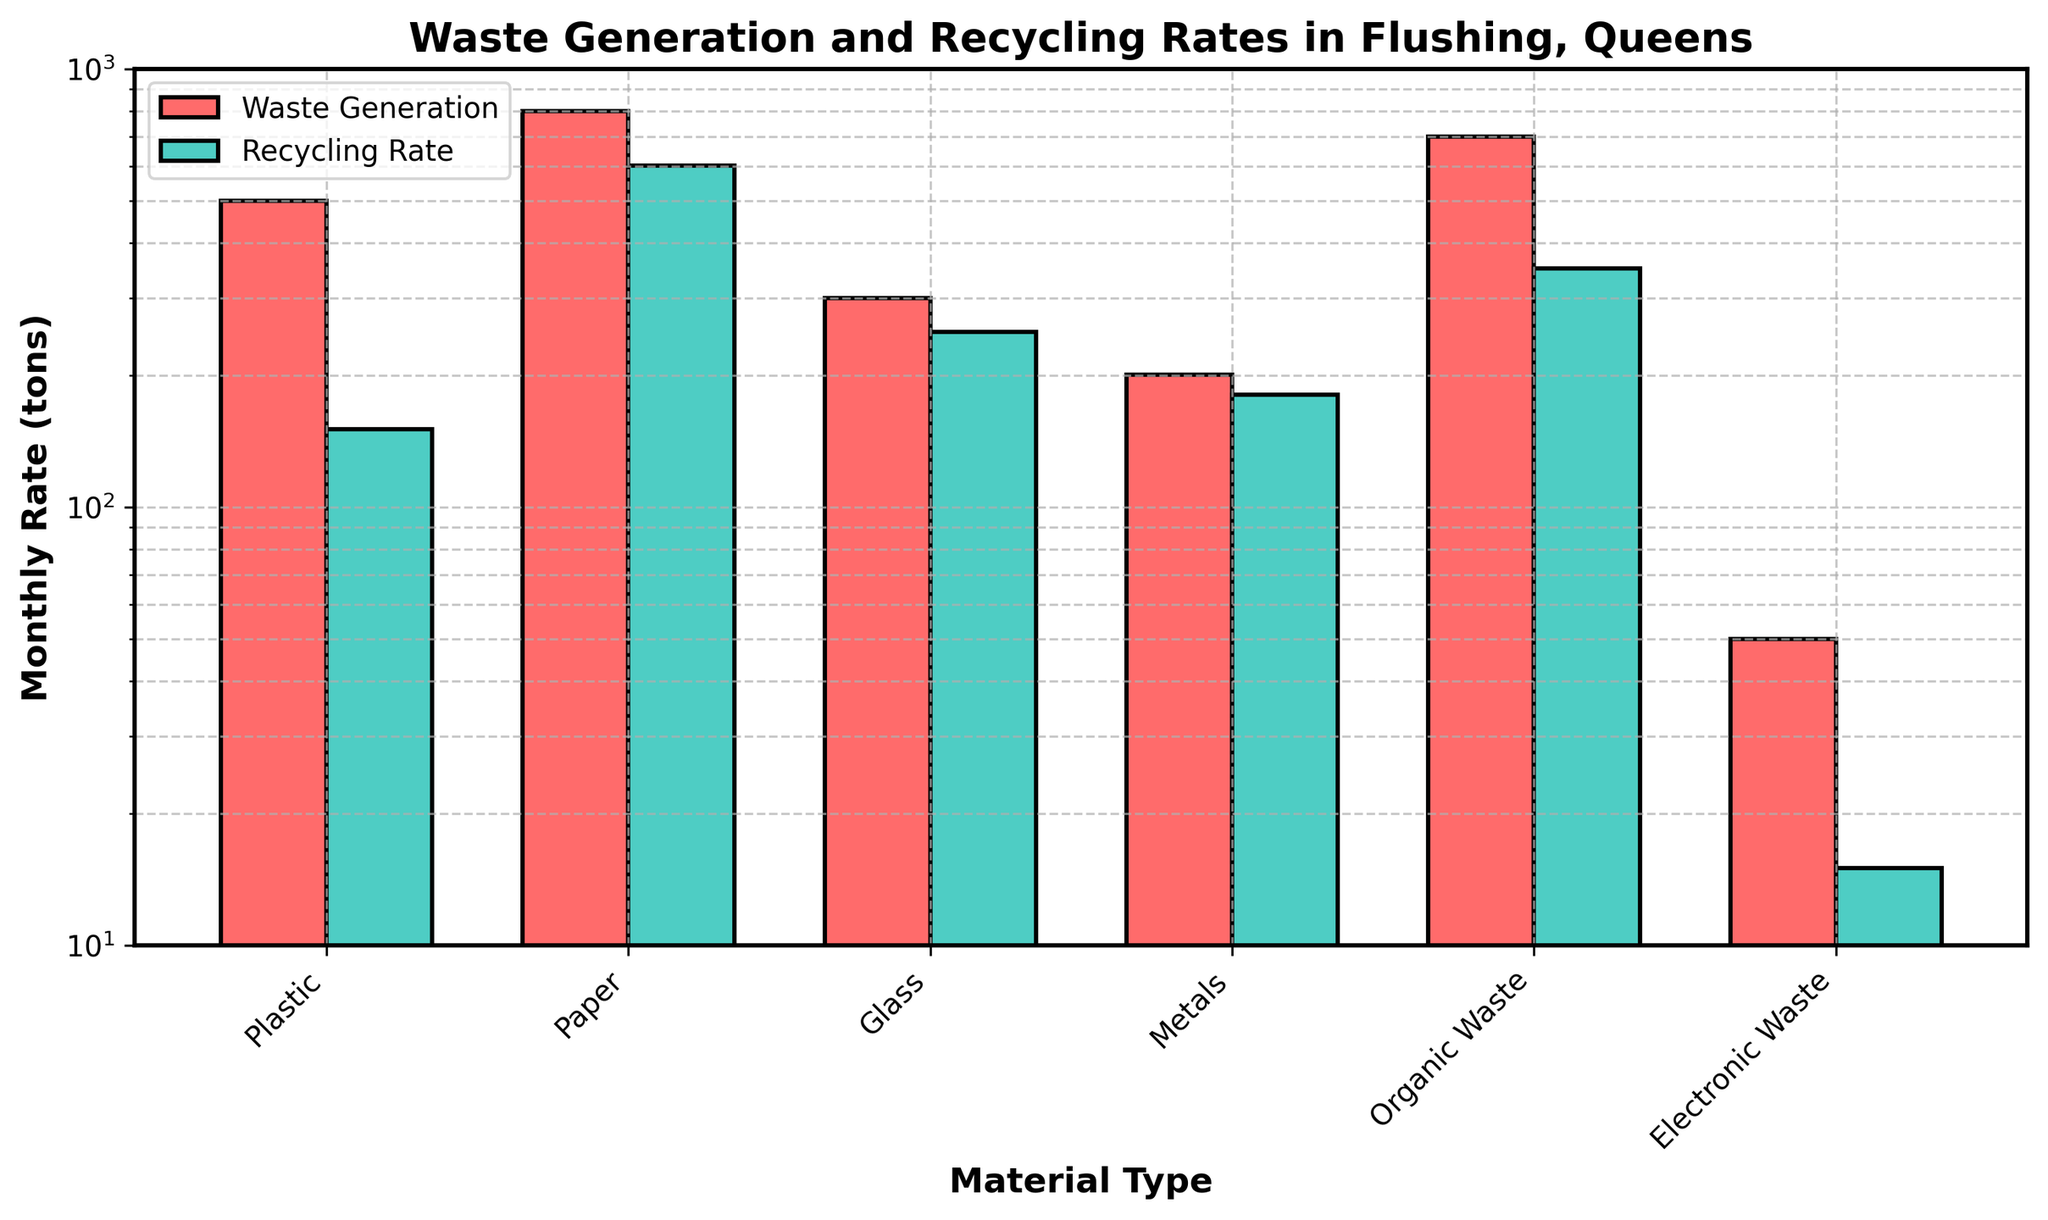what is the title of the plot? The title of the plot is displayed at the top of the figure, which typically gives an overview of what the plot is about.
Answer: Waste Generation and Recycling Rates in Flushing, Queens Which material type has the highest monthly waste generation? We can determine this by comparing the heights of the first set of bars (colored in red) for each material type. The tallest bar in this set corresponds to Paper.
Answer: Paper Which material type has the lowest monthly recycling rate? By examining the heights of the second set of bars (colored in green) for each material type, the shortest bar corresponds to Electronic Waste.
Answer: Electronic Waste How does recycling rate of plastics compare to that of metals? To compare the recycling rates, we look at the heights of the green bars for Plastic and Metals. The bar for Plastic is shorter than the bar for Metals.
Answer: Metals is higher What is the difference in monthly recycling rate between paper and glass? To find the difference, we subtract the recycling rate of Glass from that of Paper. Referring to the respective heights of the green bars, Paper's recycling rate is 600.4 tons and Glass’s is 250.7 tons. The difference is 600.4 - 250.7.
Answer: 349.7 tons Which material type has a higher monthly waste generation: organic waste or glass? By comparing the heights of the red bars, we can see that Organic Waste has a taller bar than Glass.
Answer: Organic Waste What is the ratio of waste generation to recycling rate for metals? To calculate the ratio, we divide the waste generation value by the recycling rate for Metals. This can be seen from the heights of the red and green bars for Metals; Waste generation is 200.2 and Recycling rate is 180.3. The ratio is 200.2 / 180.3.
Answer: Approximately 1.11 What can you infer about the sustainability efforts for paper based on the plot? By comparing the heights of the bars, we can infer that Paper has the highest recycling rate which is relatively close to its waste generation rate, indicating strong recycling efforts.
Answer: Highly sustainable What is the second highest recycling rate among all materials? To determine this, we compare all heights of the green bars and identify the second tallest one. After Paper (600.4), the second highest rate is for Organic Waste (350.5 tons).
Answer: Organic Waste 